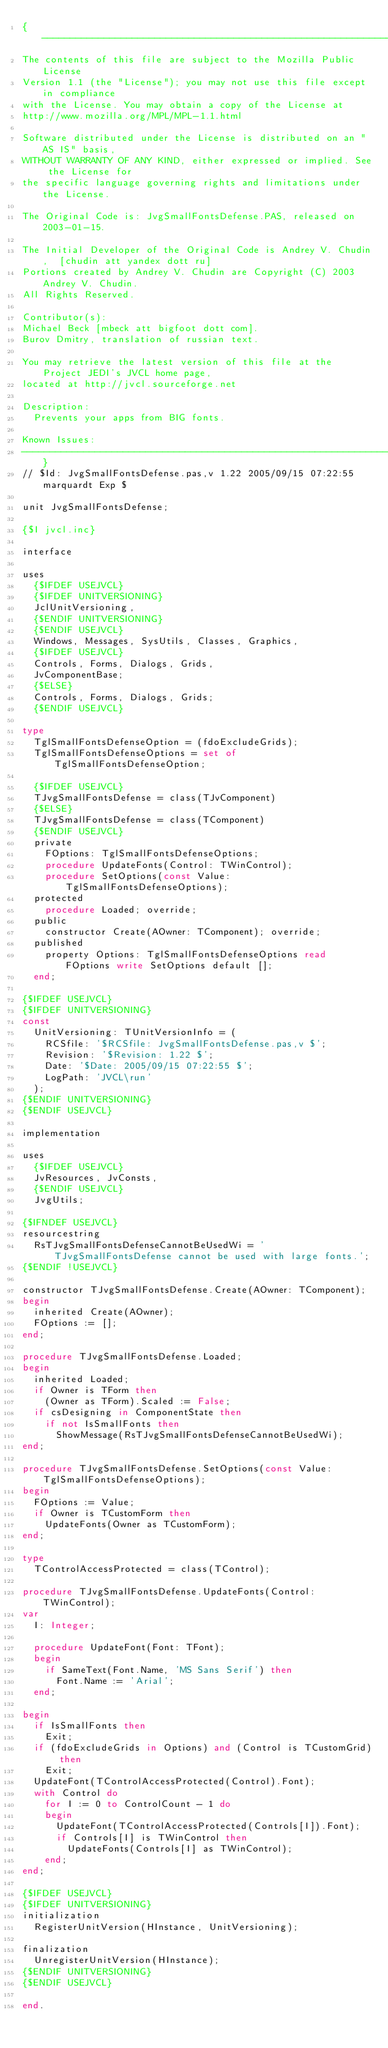Convert code to text. <code><loc_0><loc_0><loc_500><loc_500><_Pascal_>{-----------------------------------------------------------------------------
The contents of this file are subject to the Mozilla Public License
Version 1.1 (the "License"); you may not use this file except in compliance
with the License. You may obtain a copy of the License at
http://www.mozilla.org/MPL/MPL-1.1.html

Software distributed under the License is distributed on an "AS IS" basis,
WITHOUT WARRANTY OF ANY KIND, either expressed or implied. See the License for
the specific language governing rights and limitations under the License.

The Original Code is: JvgSmallFontsDefense.PAS, released on 2003-01-15.

The Initial Developer of the Original Code is Andrey V. Chudin,  [chudin att yandex dott ru]
Portions created by Andrey V. Chudin are Copyright (C) 2003 Andrey V. Chudin.
All Rights Reserved.

Contributor(s):
Michael Beck [mbeck att bigfoot dott com].
Burov Dmitry, translation of russian text.

You may retrieve the latest version of this file at the Project JEDI's JVCL home page,
located at http://jvcl.sourceforge.net

Description:
  Prevents your apps from BIG fonts.

Known Issues:
-----------------------------------------------------------------------------}
// $Id: JvgSmallFontsDefense.pas,v 1.22 2005/09/15 07:22:55 marquardt Exp $

unit JvgSmallFontsDefense;

{$I jvcl.inc}

interface

uses
  {$IFDEF USEJVCL}
  {$IFDEF UNITVERSIONING}
  JclUnitVersioning,
  {$ENDIF UNITVERSIONING}
  {$ENDIF USEJVCL}
  Windows, Messages, SysUtils, Classes, Graphics,
  {$IFDEF USEJVCL}
  Controls, Forms, Dialogs, Grids,
  JvComponentBase;
  {$ELSE}
  Controls, Forms, Dialogs, Grids;
  {$ENDIF USEJVCL}

type
  TglSmallFontsDefenseOption = (fdoExcludeGrids);
  TglSmallFontsDefenseOptions = set of TglSmallFontsDefenseOption;

  {$IFDEF USEJVCL}
  TJvgSmallFontsDefense = class(TJvComponent)
  {$ELSE}
  TJvgSmallFontsDefense = class(TComponent)
  {$ENDIF USEJVCL}
  private
    FOptions: TglSmallFontsDefenseOptions;
    procedure UpdateFonts(Control: TWinControl);
    procedure SetOptions(const Value: TglSmallFontsDefenseOptions);
  protected
    procedure Loaded; override;
  public
    constructor Create(AOwner: TComponent); override;
  published
    property Options: TglSmallFontsDefenseOptions read FOptions write SetOptions default [];
  end;

{$IFDEF USEJVCL}
{$IFDEF UNITVERSIONING}
const
  UnitVersioning: TUnitVersionInfo = (
    RCSfile: '$RCSfile: JvgSmallFontsDefense.pas,v $';
    Revision: '$Revision: 1.22 $';
    Date: '$Date: 2005/09/15 07:22:55 $';
    LogPath: 'JVCL\run'
  );
{$ENDIF UNITVERSIONING}
{$ENDIF USEJVCL}

implementation

uses
  {$IFDEF USEJVCL}
  JvResources, JvConsts,
  {$ENDIF USEJVCL}
  JvgUtils;

{$IFNDEF USEJVCL}
resourcestring
  RsTJvgSmallFontsDefenseCannotBeUsedWi = 'TJvgSmallFontsDefense cannot be used with large fonts.';
{$ENDIF !USEJVCL}

constructor TJvgSmallFontsDefense.Create(AOwner: TComponent);
begin
  inherited Create(AOwner);
  FOptions := [];
end;

procedure TJvgSmallFontsDefense.Loaded;
begin
  inherited Loaded;
  if Owner is TForm then
    (Owner as TForm).Scaled := False;
  if csDesigning in ComponentState then
    if not IsSmallFonts then
      ShowMessage(RsTJvgSmallFontsDefenseCannotBeUsedWi);
end;

procedure TJvgSmallFontsDefense.SetOptions(const Value: TglSmallFontsDefenseOptions);
begin
  FOptions := Value;
  if Owner is TCustomForm then
    UpdateFonts(Owner as TCustomForm);
end;

type
  TControlAccessProtected = class(TControl);

procedure TJvgSmallFontsDefense.UpdateFonts(Control: TWinControl);
var
  I: Integer;

  procedure UpdateFont(Font: TFont);
  begin
    if SameText(Font.Name, 'MS Sans Serif') then
      Font.Name := 'Arial';
  end;

begin
  if IsSmallFonts then
    Exit;
  if (fdoExcludeGrids in Options) and (Control is TCustomGrid) then
    Exit;
  UpdateFont(TControlAccessProtected(Control).Font);
  with Control do
    for I := 0 to ControlCount - 1 do
    begin
      UpdateFont(TControlAccessProtected(Controls[I]).Font);
      if Controls[I] is TWinControl then
        UpdateFonts(Controls[I] as TWinControl);
    end;
end;

{$IFDEF USEJVCL}
{$IFDEF UNITVERSIONING}
initialization
  RegisterUnitVersion(HInstance, UnitVersioning);

finalization
  UnregisterUnitVersion(HInstance);
{$ENDIF UNITVERSIONING}
{$ENDIF USEJVCL}

end.

</code> 